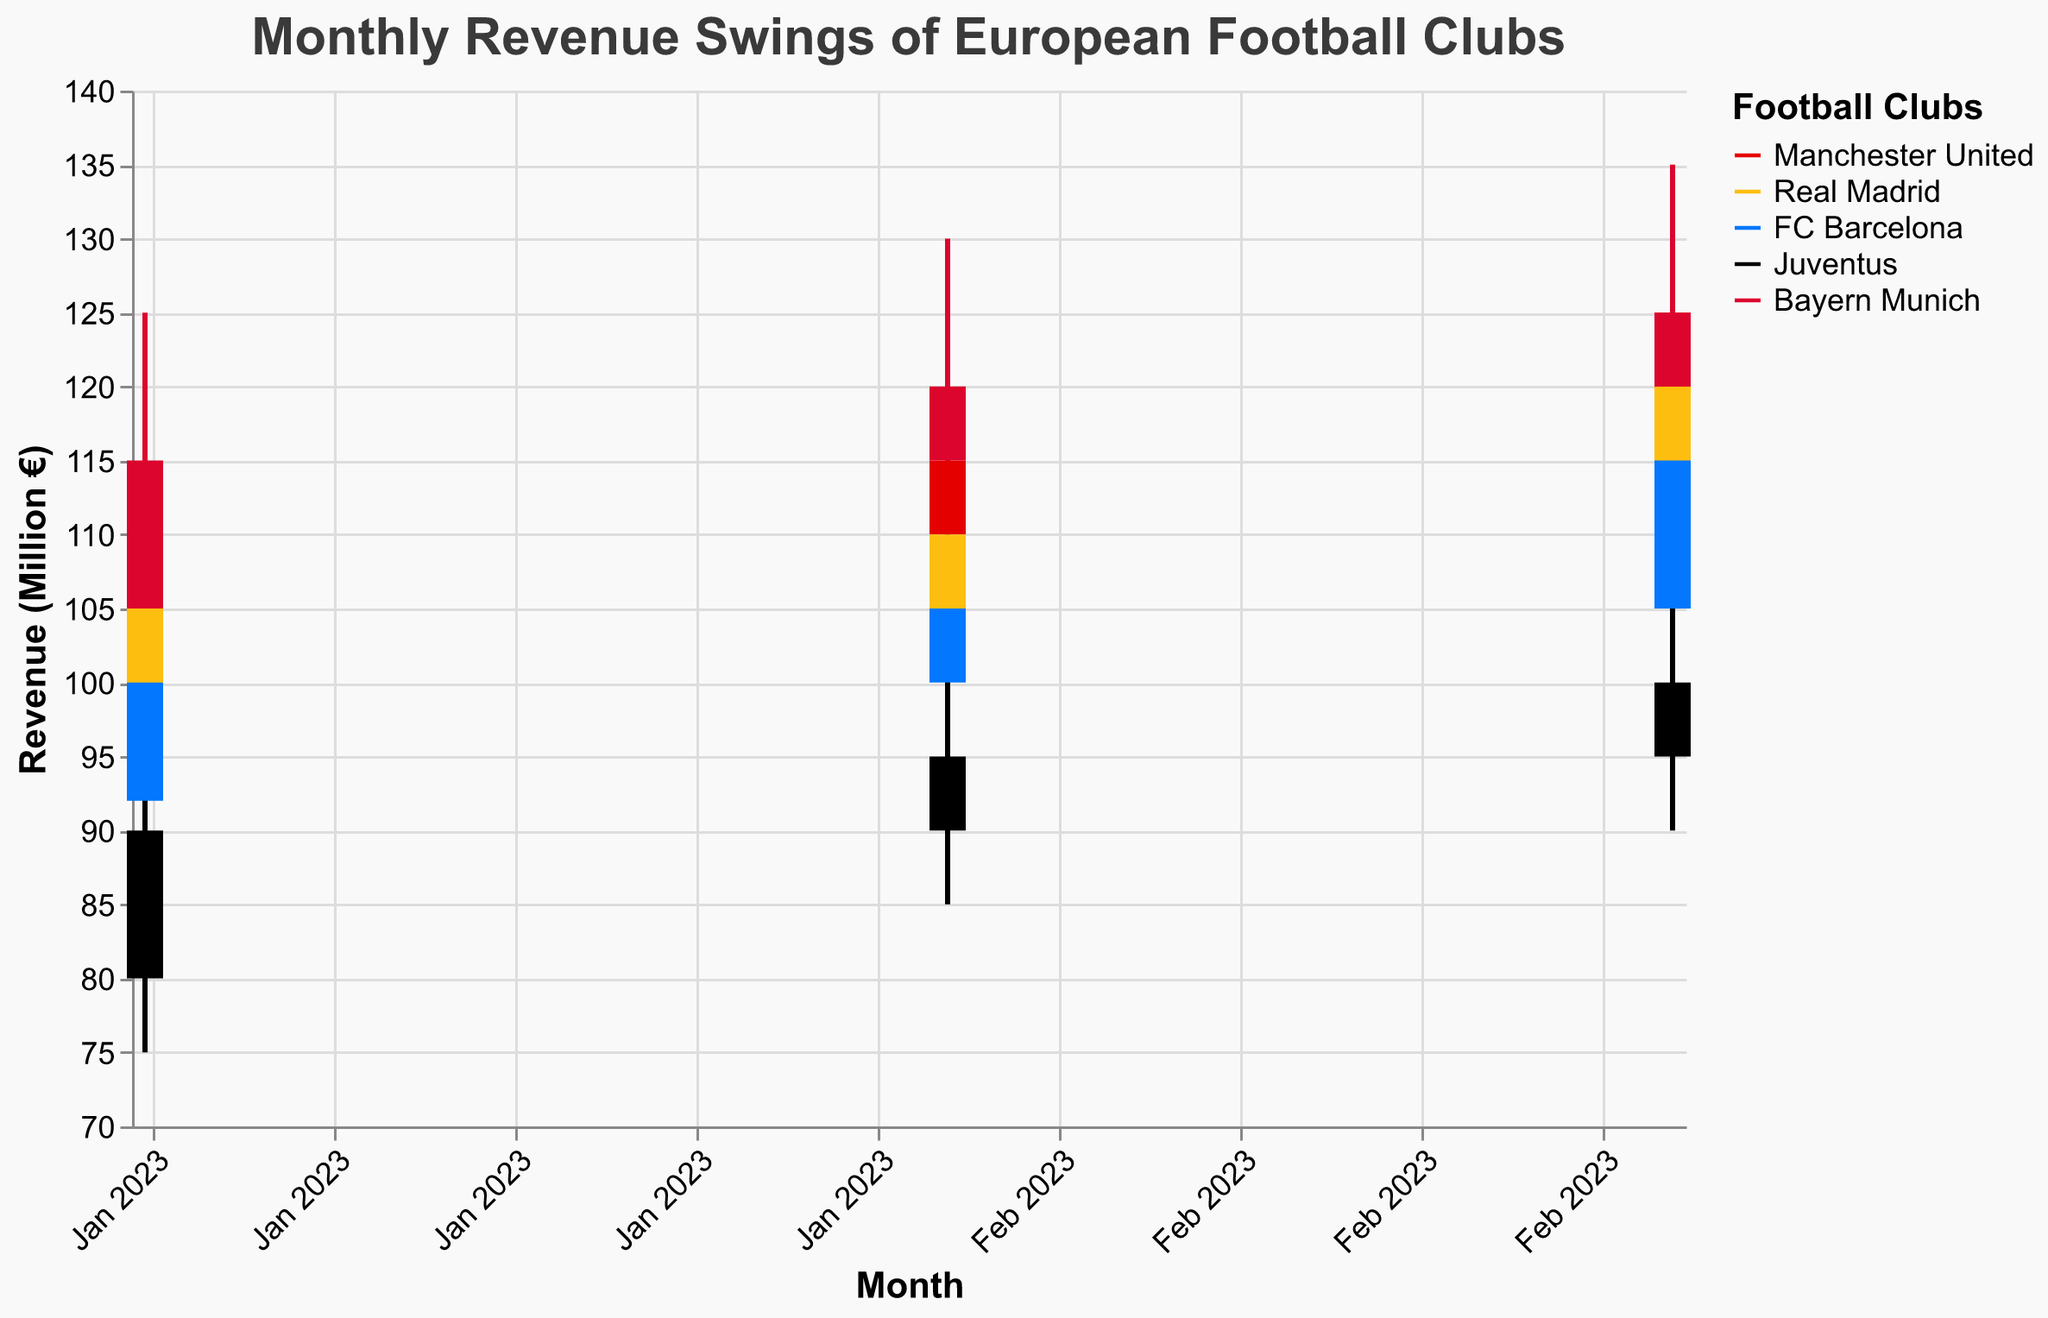What is the title of the figure? The title is located at the top of the figure and provides a summary of what the plot is about. The text of the title can be read directly from this location.
Answer: Monthly Revenue Swings of European Football Clubs How many football clubs are represented in the figure? Each unique color in the legend represents a football club. By counting these colors, we can determine the number of clubs.
Answer: 5 Which club had the highest revenue (Close value) in January 2023? By inspecting the Close values for January 2023 for each club in the candlestick plots, we can find the highest value. Bayern Munich has the highest Close value of 115.
Answer: Bayern Munich What is the range of revenue (Low to High) for Real Madrid in February 2023? Look at the candlestick for Real Madrid in February 2023. The Low value is 100 and the High value is 120. The range is calculated as 120 - 100.
Answer: 20 Which club experienced the most significant increase in revenue from January to March 2023? Calculate the increase in Close value from January to March for each club. For Manchester United: 125-110=15, Real Madrid: 120-105=15, FC Barcelona: 115-100=15, Juventus: 100-90=10, Bayern Munich: 125-115=10. Manchester United, Real Madrid, and FC Barcelona had the largest increases, each with an increase of 15 million euros.
Answer: Manchester United, Real Madrid, FC Barcelona What was the average closing revenue for Bayern Munich over the three months? Calculate the average Close value for Bayern Munich from January to March: (115 + 120 + 125) / 3. This results in (115 + 120 + 125) / 3 = 120.
Answer: 120 Compare the opening revenues of FC Barcelona and Juventus in March 2023. Which club had a higher opening revenue? Look at the Open values in March 2023 for both clubs. FC Barcelona has an Open value of 105 and Juventus has an Open value of 95. FC Barcelona's opening revenue is higher.
Answer: FC Barcelona For which month did all clubs experience a positive closing revenue (Close > Open)? Examine each candlestick plot for all months and compare the Open and Close values. January: Manchester United, Real Madrid, FC Barcelona, Juventus, and Bayern Munich all have positive Close values. February and March also have positive closing values for all clubs. All clubs experienced a positive closing revenue in each month.
Answer: All months Which club had the highest single-month revenue swing (High minus Low) in the data? Inspect the High and Low values for each club across all months. Calculate the swings: Manchester United: 130-110=20, Real Madrid: 125-105=20, FC Barcelona: 120-100=20, Juventus: 110-90=20, Bayern Munich: 135-115=20. Bayern Munich in March has the highest swing of 20 million euros.
Answer: Bayern Munich 